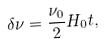Convert formula to latex. <formula><loc_0><loc_0><loc_500><loc_500>\delta \nu = \frac { \nu _ { 0 } } { 2 } H _ { 0 } t ,</formula> 